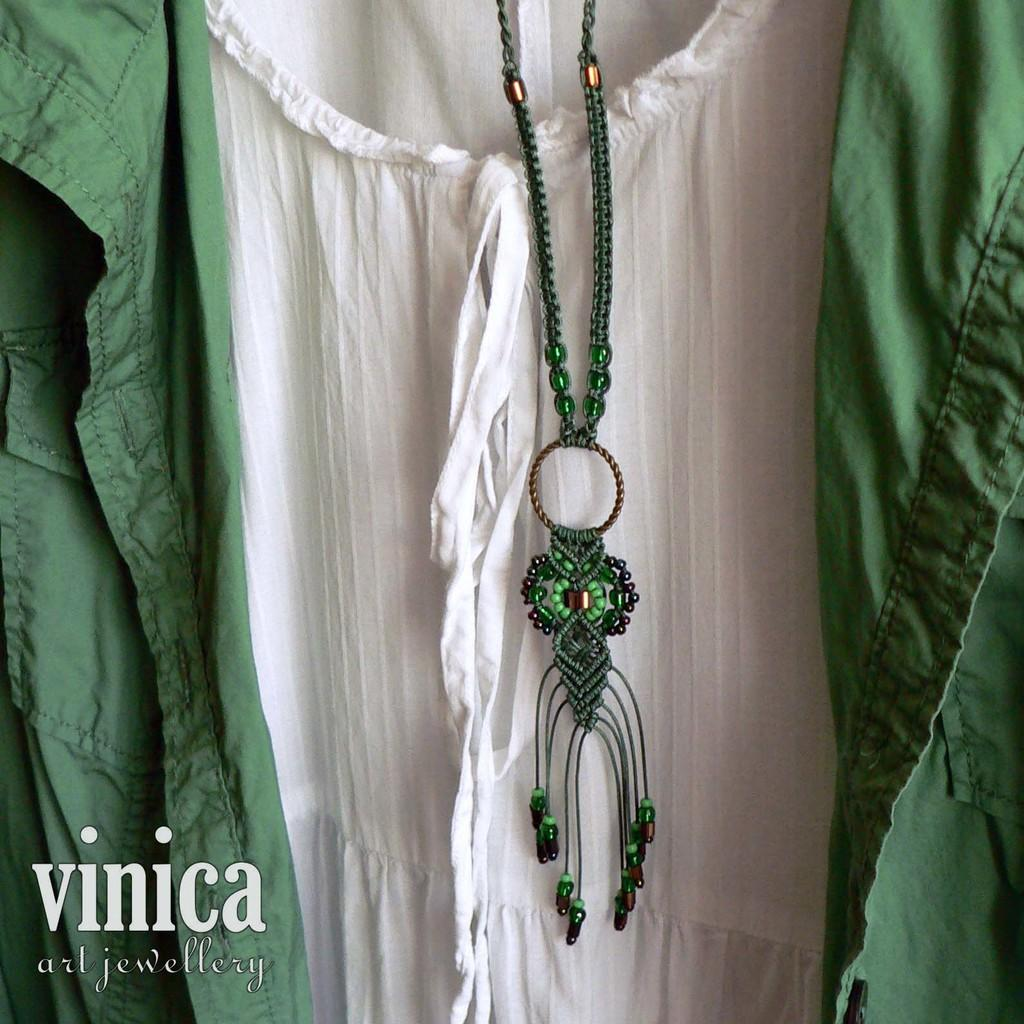What type of clothing item is in the picture? There is a dress in the picture. Can you describe the color pattern of the dress? The dress has a green and white color pattern. What type of accessory is the dress paired with? The dress has a green color necklace. What is the name of the brand or designer near the dress? The name "Vinica art jewelry" is near the dress. How does the dress exhibit good behavior in the image? The dress does not exhibit any behavior in the image, as it is an inanimate object. 